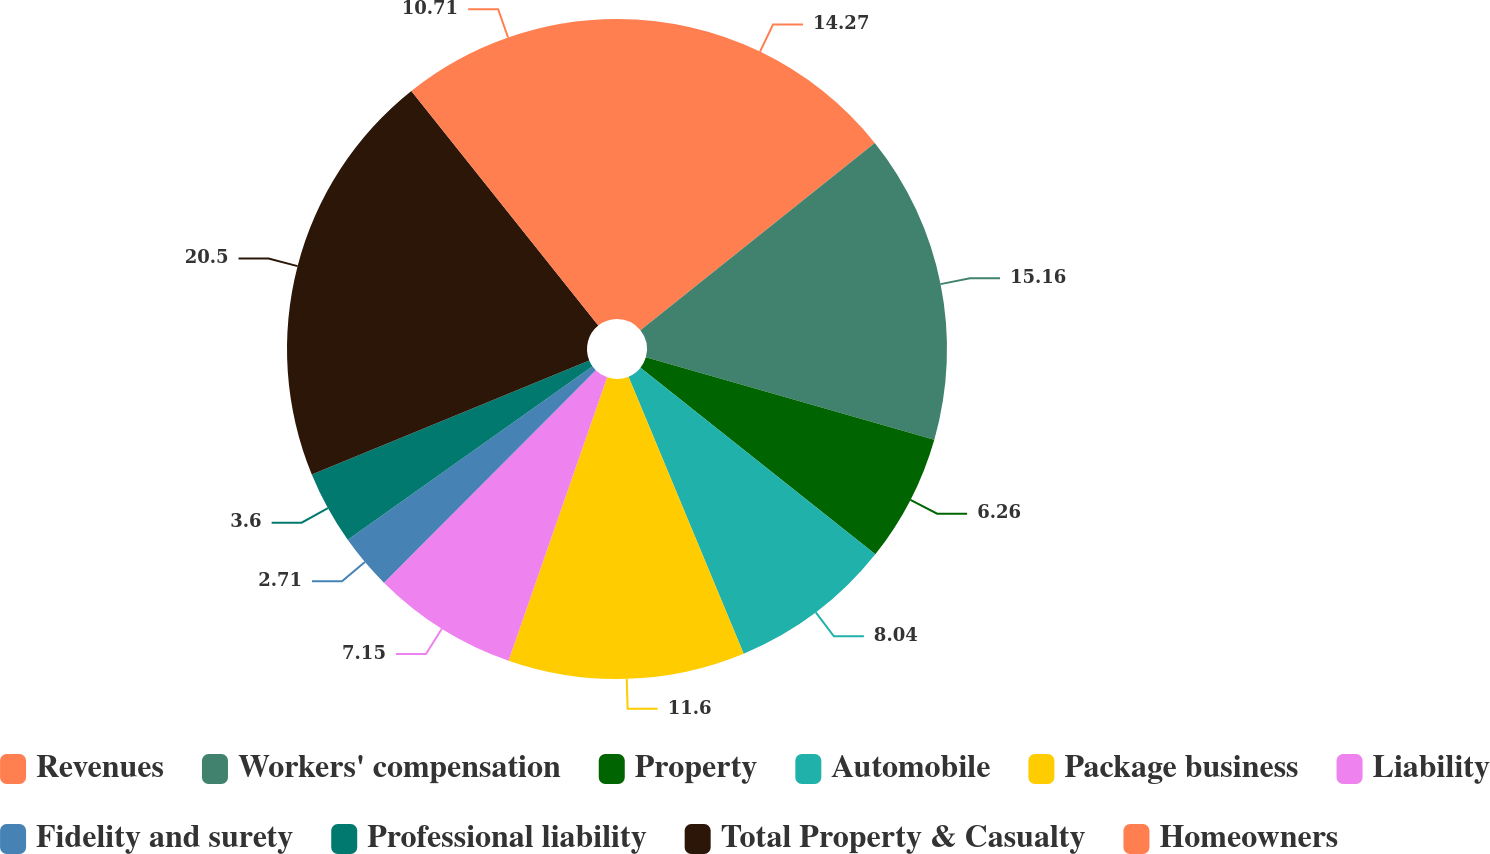<chart> <loc_0><loc_0><loc_500><loc_500><pie_chart><fcel>Revenues<fcel>Workers' compensation<fcel>Property<fcel>Automobile<fcel>Package business<fcel>Liability<fcel>Fidelity and surety<fcel>Professional liability<fcel>Total Property & Casualty<fcel>Homeowners<nl><fcel>14.27%<fcel>15.16%<fcel>6.26%<fcel>8.04%<fcel>11.6%<fcel>7.15%<fcel>2.71%<fcel>3.6%<fcel>20.5%<fcel>10.71%<nl></chart> 